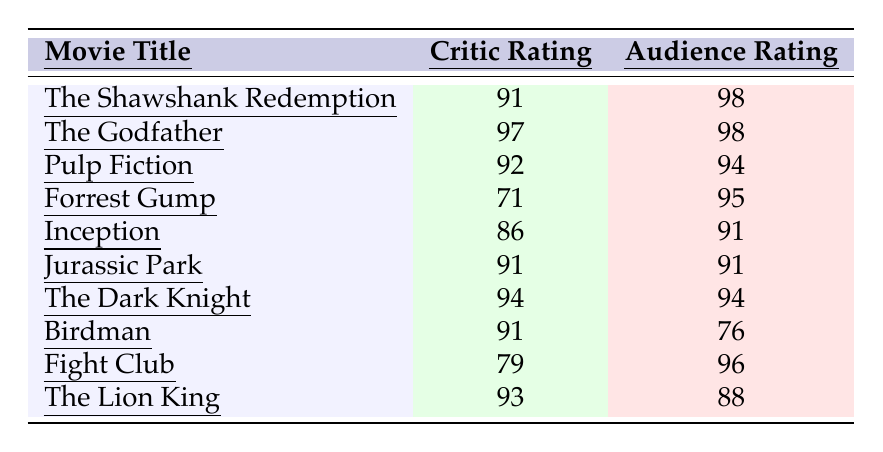What is the critic rating of "The Godfather"? The table lists the critic rating for each movie. For "The Godfather," the critic rating is shown as 97.
Answer: 97 Which movie has the highest audience rating? The audience ratings for all movies are compared. "The Shawshank Redemption" and "The Godfather" both have the highest rating at 98.
Answer: The Shawshank Redemption and The Godfather What is the difference between the critic rating and audience rating for "Forrest Gump"? The critic rating for "Forrest Gump" is 71 and the audience rating is 95. The difference is calculated as 95 - 71 = 24.
Answer: 24 Is the critic rating for "Birdman" higher than its audience rating? The critic rating for "Birdman" is 91 while the audience rating is 76. Since 91 is greater than 76, the answer is yes.
Answer: Yes What is the average critic rating for all movies listed? The critic ratings are: 91, 97, 92, 71, 86, 91, 94, 91, 79, 93. The total is  91 + 97 + 92 + 71 + 86 + 91 + 94 + 91 + 79 + 93 =  915. There are 10 movies, so the average is 915 / 10 = 91.5.
Answer: 91.5 For how many movies is the audience rating lower than the critic rating? Comparing the tables, the audience rating is lower than the critic rating only for "Birdman", which has a critic rating of 91 and an audience rating of 76. Thus, there is 1 movie.
Answer: 1 What percentage of movies have an audience rating of 90 or above? The movies with audience ratings of 90 or above are: "The Shawshank Redemption" (98), "The Godfather" (98), "Forrest Gump" (95), "Inception" (91), "Jurassic Park" (91), "The Dark Knight" (94), "Fight Club" (96). Out of 10 movies, 7 meet this criterion, so the percentage is (7/10) * 100 = 70%.
Answer: 70% Which movie has the largest gap between critic and audience rating? Calculate the differences: "The Shawshank Redemption" (7), "The Godfather" (1), "Pulp Fiction" (2), "Forrest Gump" (24), "Inception" (5), "Jurassic Park" (0), "The Dark Knight" (0), "Birdman" (15), "Fight Club" (17), and "The Lion King" (5). The largest gap is 24 for "Forrest Gump".
Answer: Forrest Gump How many movies have a critic rating below 80? The movies with critic ratings below 80 are "Forrest Gump" (71) and "Fight Club" (79). Thus, there are 2 movies that meet this criterion.
Answer: 2 Is it true that all movies have audience ratings of at least 70? Checking the audience ratings, "Birdman" has a rating of 76, which is above 70; "Fight Club" has a rating of 96, and all other movies are also above 70. Therefore, it is true that all movies have audience ratings of at least 70.
Answer: Yes 